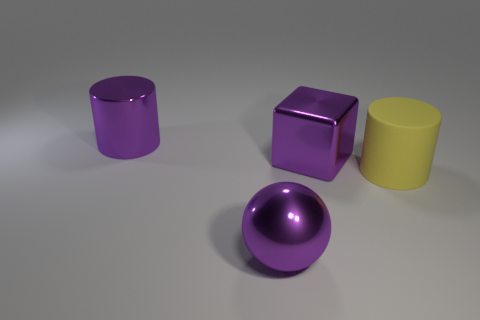Is there anything else that is the same material as the purple cylinder?
Offer a very short reply. Yes. What shape is the purple metallic object that is both left of the purple block and behind the yellow cylinder?
Make the answer very short. Cylinder. What is the size of the purple block that is the same material as the large purple cylinder?
Offer a very short reply. Large. There is a large shiny object that is in front of the large yellow object; what number of purple cubes are behind it?
Your answer should be compact. 1. Is the thing in front of the large yellow rubber cylinder made of the same material as the purple block?
Offer a very short reply. Yes. There is a purple thing that is in front of the large metal block; does it have the same shape as the purple metallic object right of the purple metal sphere?
Ensure brevity in your answer.  No. What number of other objects are there of the same color as the shiny ball?
Offer a terse response. 2. There is a thing that is in front of the matte object; is its size the same as the yellow thing?
Your answer should be very brief. Yes. Is the cylinder that is behind the large purple block made of the same material as the purple thing that is in front of the big metallic block?
Make the answer very short. Yes. Are there any red metallic balls that have the same size as the metal cube?
Offer a very short reply. No. 